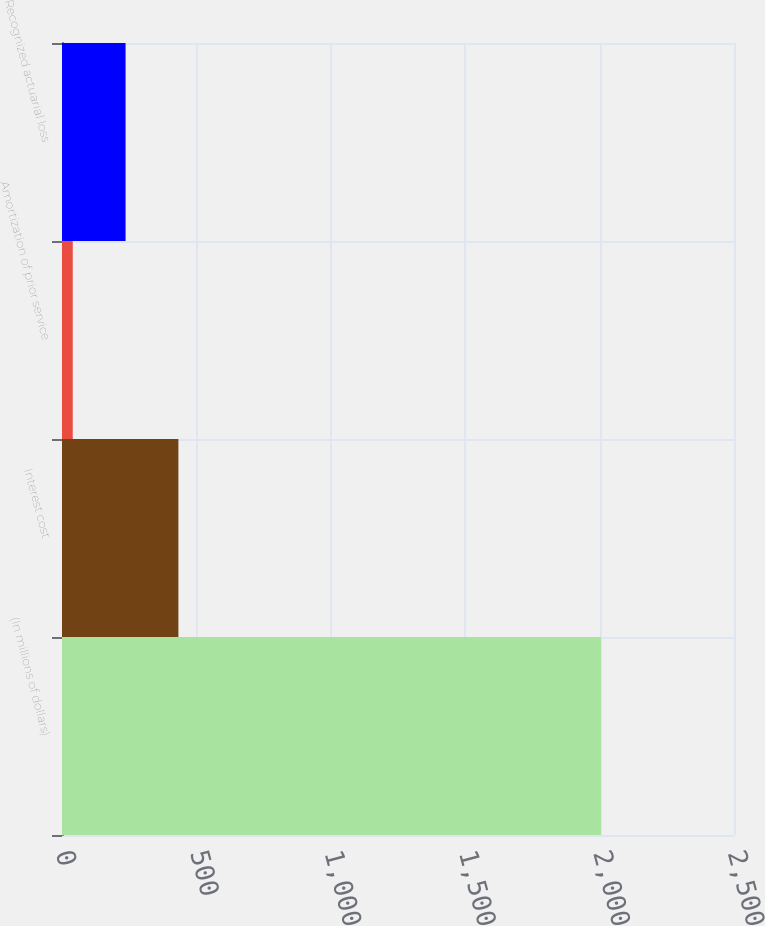<chart> <loc_0><loc_0><loc_500><loc_500><bar_chart><fcel>(In millions of dollars)<fcel>Interest cost<fcel>Amortization of prior service<fcel>Recognized actuarial loss<nl><fcel>2005<fcel>433<fcel>40<fcel>236.5<nl></chart> 